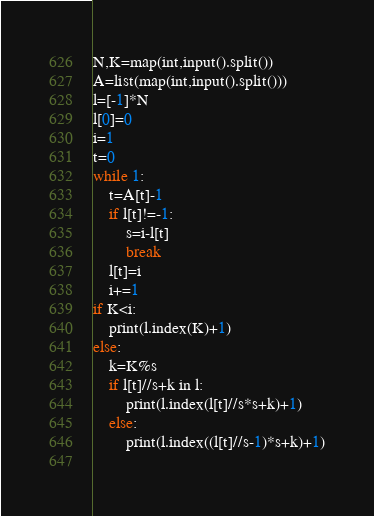Convert code to text. <code><loc_0><loc_0><loc_500><loc_500><_Python_>N,K=map(int,input().split())
A=list(map(int,input().split()))
l=[-1]*N
l[0]=0
i=1
t=0
while 1:
    t=A[t]-1
    if l[t]!=-1:
        s=i-l[t]
        break
    l[t]=i
    i+=1
if K<i:
    print(l.index(K)+1)
else:
    k=K%s
    if l[t]//s+k in l:
        print(l.index(l[t]//s*s+k)+1)
    else:
        print(l.index((l[t]//s-1)*s+k)+1)
    
</code> 